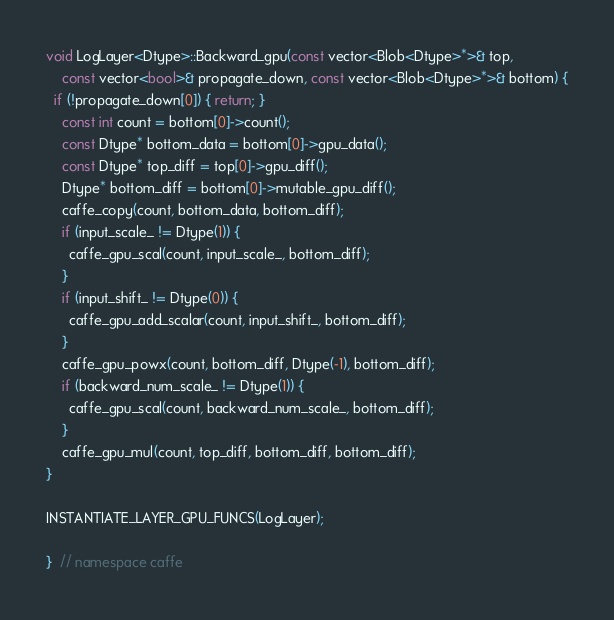<code> <loc_0><loc_0><loc_500><loc_500><_Cuda_>void LogLayer<Dtype>::Backward_gpu(const vector<Blob<Dtype>*>& top,
    const vector<bool>& propagate_down, const vector<Blob<Dtype>*>& bottom) {
  if (!propagate_down[0]) { return; }
    const int count = bottom[0]->count();
    const Dtype* bottom_data = bottom[0]->gpu_data();
    const Dtype* top_diff = top[0]->gpu_diff();
    Dtype* bottom_diff = bottom[0]->mutable_gpu_diff();
    caffe_copy(count, bottom_data, bottom_diff);
    if (input_scale_ != Dtype(1)) {
      caffe_gpu_scal(count, input_scale_, bottom_diff);
    }
    if (input_shift_ != Dtype(0)) {
      caffe_gpu_add_scalar(count, input_shift_, bottom_diff);
    }
    caffe_gpu_powx(count, bottom_diff, Dtype(-1), bottom_diff);
    if (backward_num_scale_ != Dtype(1)) {
      caffe_gpu_scal(count, backward_num_scale_, bottom_diff);
    }
    caffe_gpu_mul(count, top_diff, bottom_diff, bottom_diff);
}

INSTANTIATE_LAYER_GPU_FUNCS(LogLayer);

}  // namespace caffe
</code> 